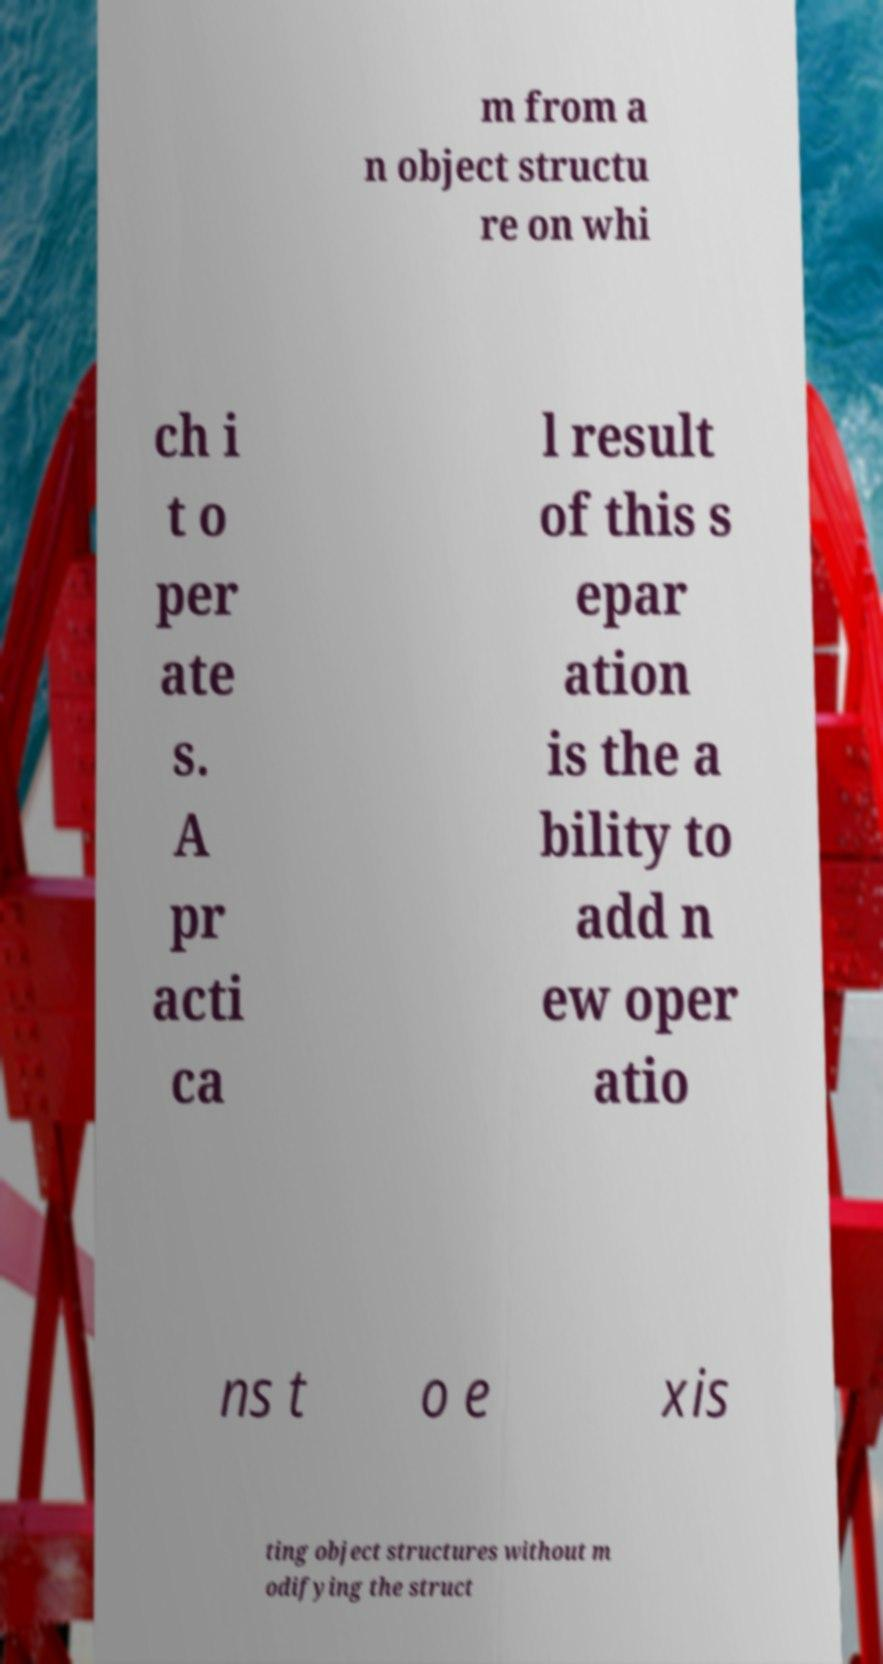There's text embedded in this image that I need extracted. Can you transcribe it verbatim? m from a n object structu re on whi ch i t o per ate s. A pr acti ca l result of this s epar ation is the a bility to add n ew oper atio ns t o e xis ting object structures without m odifying the struct 